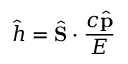<formula> <loc_0><loc_0><loc_500><loc_500>{ \hat { h } } = { \hat { S } } \cdot { \frac { c { \hat { p } } } { E } }</formula> 